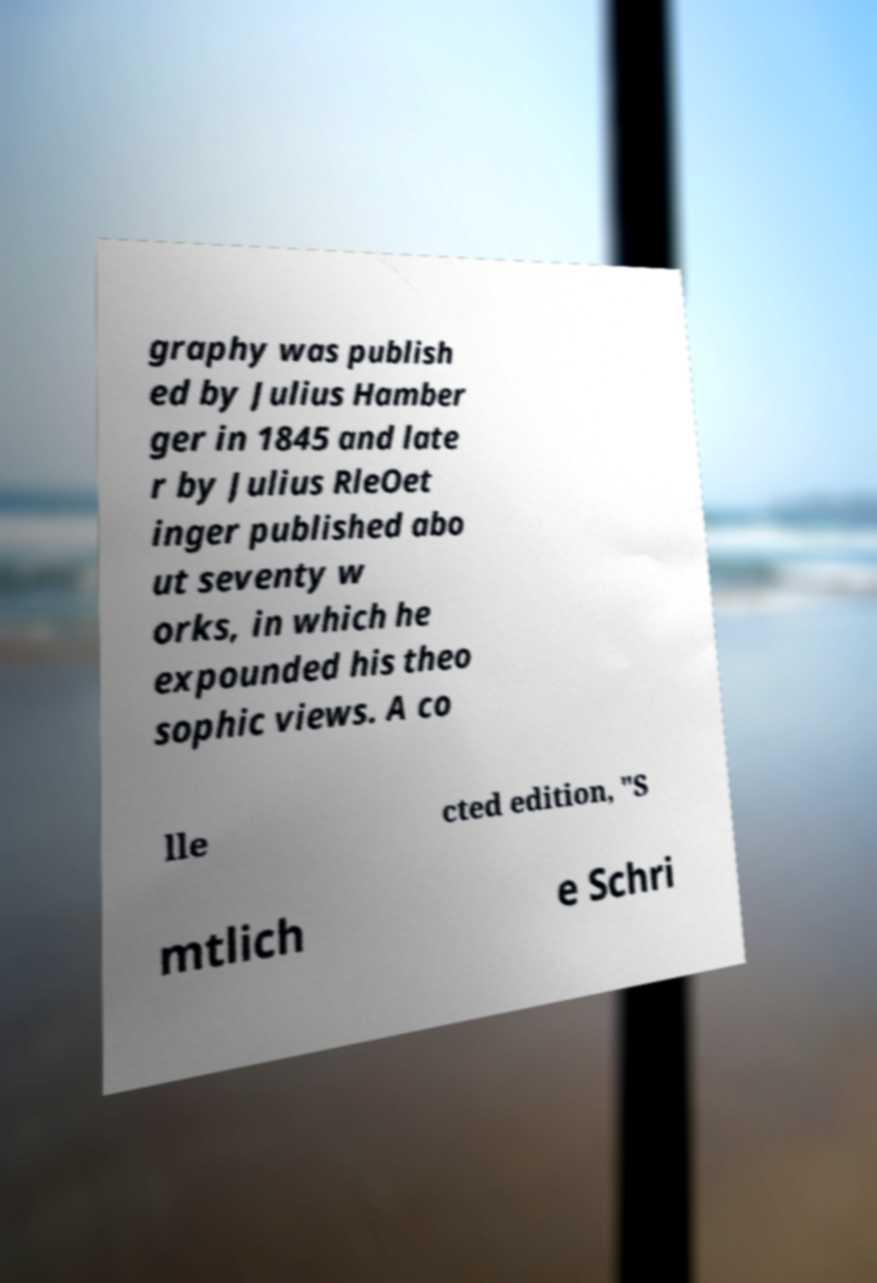Could you assist in decoding the text presented in this image and type it out clearly? graphy was publish ed by Julius Hamber ger in 1845 and late r by Julius RleOet inger published abo ut seventy w orks, in which he expounded his theo sophic views. A co lle cted edition, "S mtlich e Schri 